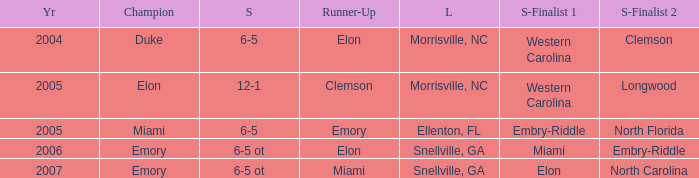List the scores of all games when Miami were listed as the first Semi finalist 6-5 ot. 